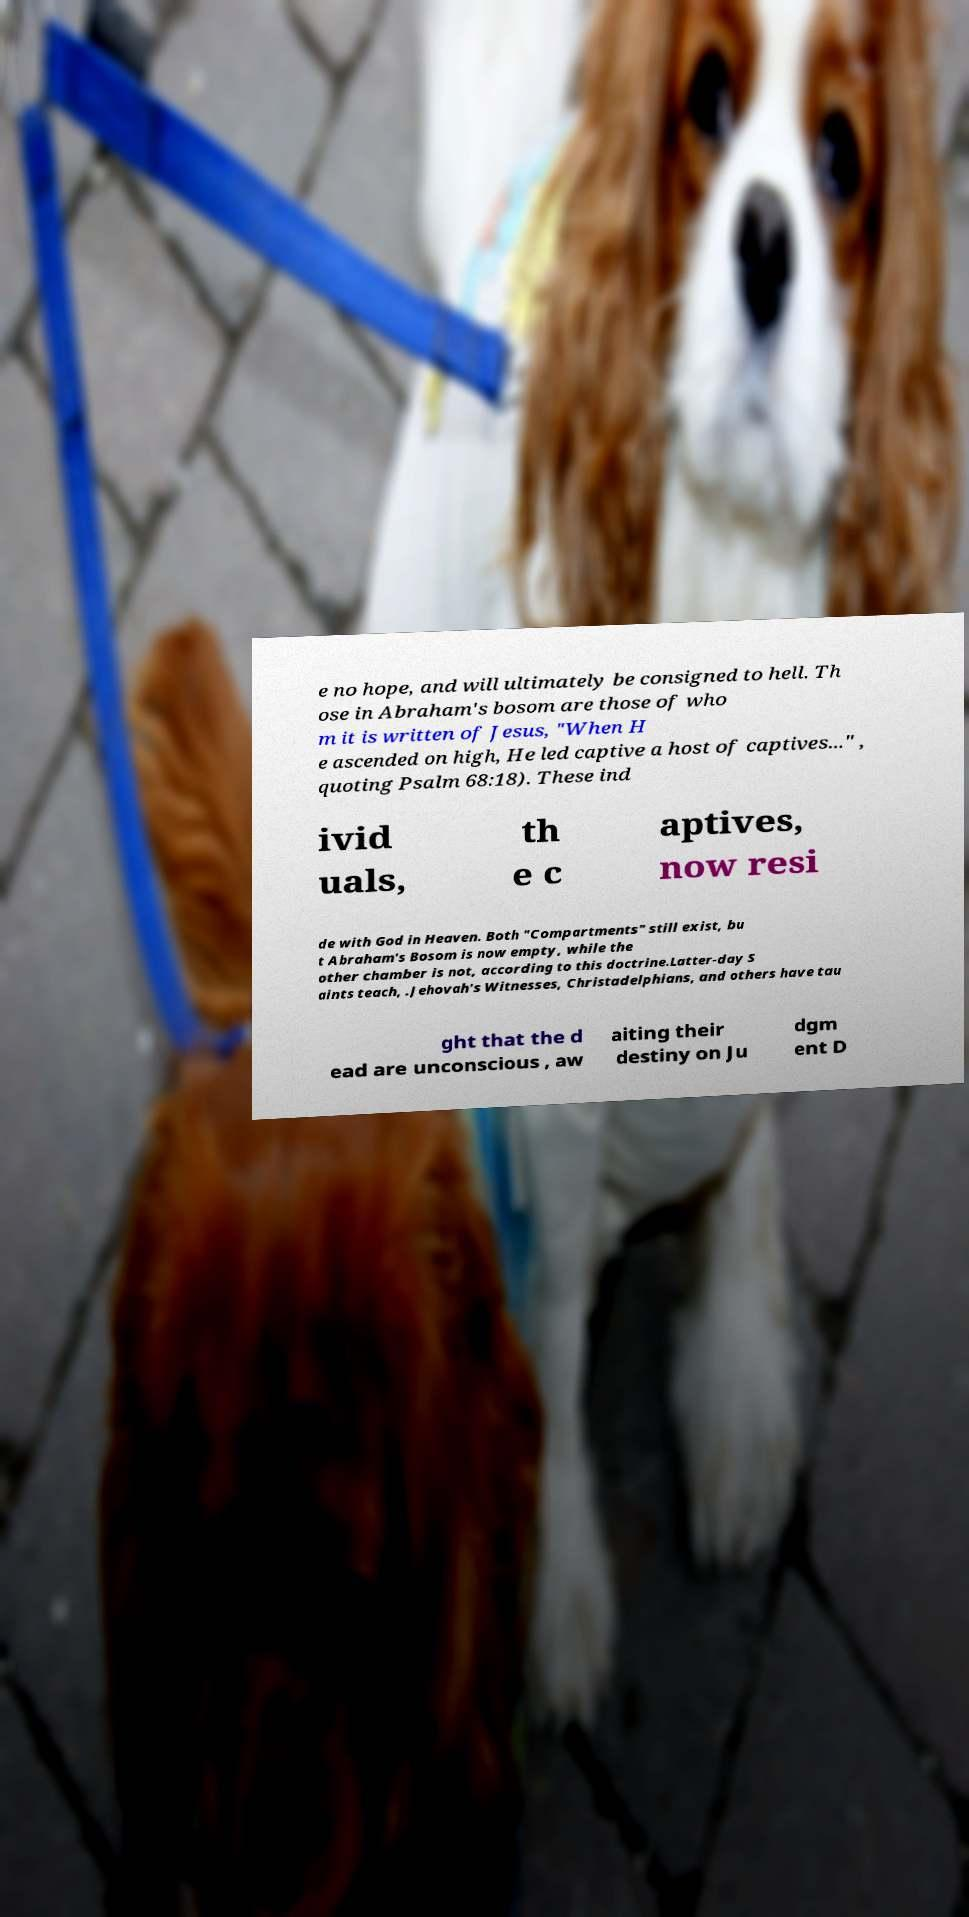Can you accurately transcribe the text from the provided image for me? e no hope, and will ultimately be consigned to hell. Th ose in Abraham's bosom are those of who m it is written of Jesus, "When H e ascended on high, He led captive a host of captives..." , quoting Psalm 68:18). These ind ivid uals, th e c aptives, now resi de with God in Heaven. Both "Compartments" still exist, bu t Abraham's Bosom is now empty, while the other chamber is not, according to this doctrine.Latter-day S aints teach, .Jehovah's Witnesses, Christadelphians, and others have tau ght that the d ead are unconscious , aw aiting their destiny on Ju dgm ent D 